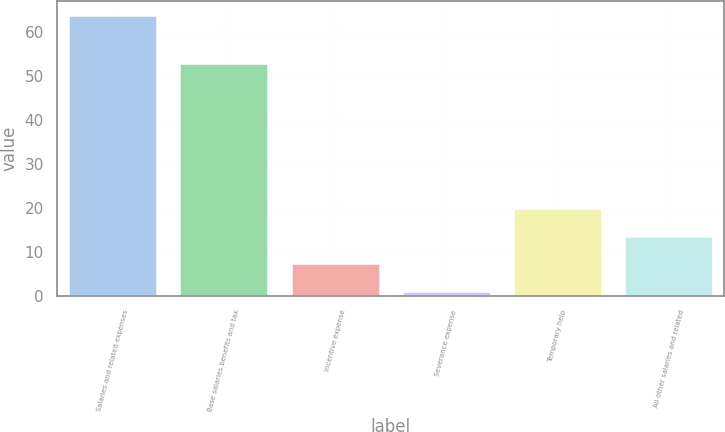Convert chart. <chart><loc_0><loc_0><loc_500><loc_500><bar_chart><fcel>Salaries and related expenses<fcel>Base salaries benefits and tax<fcel>Incentive expense<fcel>Severance expense<fcel>Temporary help<fcel>All other salaries and related<nl><fcel>63.8<fcel>52.9<fcel>7.37<fcel>1.1<fcel>19.91<fcel>13.64<nl></chart> 